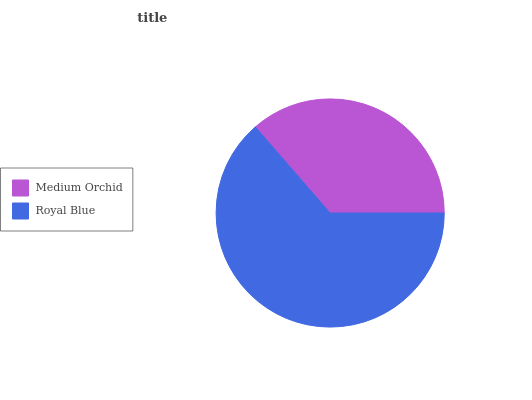Is Medium Orchid the minimum?
Answer yes or no. Yes. Is Royal Blue the maximum?
Answer yes or no. Yes. Is Royal Blue the minimum?
Answer yes or no. No. Is Royal Blue greater than Medium Orchid?
Answer yes or no. Yes. Is Medium Orchid less than Royal Blue?
Answer yes or no. Yes. Is Medium Orchid greater than Royal Blue?
Answer yes or no. No. Is Royal Blue less than Medium Orchid?
Answer yes or no. No. Is Royal Blue the high median?
Answer yes or no. Yes. Is Medium Orchid the low median?
Answer yes or no. Yes. Is Medium Orchid the high median?
Answer yes or no. No. Is Royal Blue the low median?
Answer yes or no. No. 